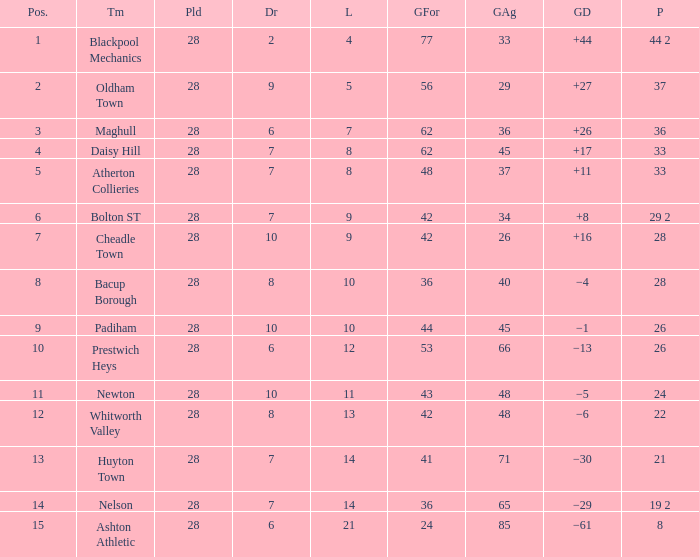What is the lowest drawn for entries with a lost of 13? 8.0. 